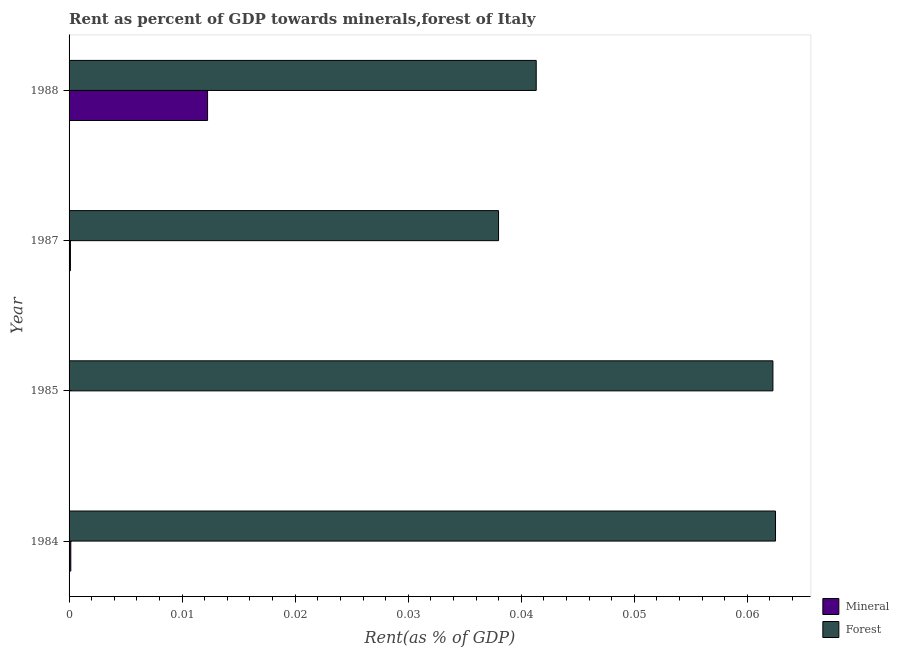How many different coloured bars are there?
Provide a short and direct response. 2. Are the number of bars per tick equal to the number of legend labels?
Provide a short and direct response. Yes. How many bars are there on the 4th tick from the top?
Ensure brevity in your answer.  2. In how many cases, is the number of bars for a given year not equal to the number of legend labels?
Provide a succinct answer. 0. What is the forest rent in 1984?
Ensure brevity in your answer.  0.06. Across all years, what is the maximum mineral rent?
Offer a terse response. 0.01. Across all years, what is the minimum forest rent?
Make the answer very short. 0.04. In which year was the mineral rent maximum?
Give a very brief answer. 1988. What is the total forest rent in the graph?
Offer a very short reply. 0.2. What is the difference between the forest rent in 1985 and that in 1988?
Provide a short and direct response. 0.02. What is the difference between the mineral rent in 1988 and the forest rent in 1987?
Offer a terse response. -0.03. What is the average mineral rent per year?
Provide a succinct answer. 0. In the year 1987, what is the difference between the mineral rent and forest rent?
Provide a succinct answer. -0.04. What is the ratio of the forest rent in 1985 to that in 1987?
Offer a terse response. 1.64. Is the difference between the mineral rent in 1984 and 1988 greater than the difference between the forest rent in 1984 and 1988?
Your response must be concise. No. What is the difference between the highest and the second highest mineral rent?
Keep it short and to the point. 0.01. In how many years, is the mineral rent greater than the average mineral rent taken over all years?
Give a very brief answer. 1. Is the sum of the forest rent in 1984 and 1985 greater than the maximum mineral rent across all years?
Offer a very short reply. Yes. What does the 1st bar from the top in 1987 represents?
Offer a very short reply. Forest. What does the 2nd bar from the bottom in 1987 represents?
Your response must be concise. Forest. Does the graph contain any zero values?
Ensure brevity in your answer.  No. Does the graph contain grids?
Offer a terse response. No. How many legend labels are there?
Your answer should be very brief. 2. How are the legend labels stacked?
Offer a terse response. Vertical. What is the title of the graph?
Keep it short and to the point. Rent as percent of GDP towards minerals,forest of Italy. What is the label or title of the X-axis?
Ensure brevity in your answer.  Rent(as % of GDP). What is the Rent(as % of GDP) in Mineral in 1984?
Provide a short and direct response. 0. What is the Rent(as % of GDP) in Forest in 1984?
Your answer should be very brief. 0.06. What is the Rent(as % of GDP) in Mineral in 1985?
Provide a succinct answer. 9.961583224840801e-6. What is the Rent(as % of GDP) in Forest in 1985?
Your answer should be compact. 0.06. What is the Rent(as % of GDP) in Mineral in 1987?
Make the answer very short. 0. What is the Rent(as % of GDP) in Forest in 1987?
Ensure brevity in your answer.  0.04. What is the Rent(as % of GDP) in Mineral in 1988?
Offer a very short reply. 0.01. What is the Rent(as % of GDP) of Forest in 1988?
Your answer should be very brief. 0.04. Across all years, what is the maximum Rent(as % of GDP) in Mineral?
Offer a very short reply. 0.01. Across all years, what is the maximum Rent(as % of GDP) of Forest?
Keep it short and to the point. 0.06. Across all years, what is the minimum Rent(as % of GDP) in Mineral?
Offer a terse response. 9.961583224840801e-6. Across all years, what is the minimum Rent(as % of GDP) in Forest?
Give a very brief answer. 0.04. What is the total Rent(as % of GDP) in Mineral in the graph?
Keep it short and to the point. 0.01. What is the total Rent(as % of GDP) in Forest in the graph?
Your answer should be compact. 0.2. What is the difference between the Rent(as % of GDP) of Mineral in 1984 and that in 1985?
Offer a very short reply. 0. What is the difference between the Rent(as % of GDP) of Forest in 1984 and that in 1987?
Make the answer very short. 0.02. What is the difference between the Rent(as % of GDP) in Mineral in 1984 and that in 1988?
Offer a terse response. -0.01. What is the difference between the Rent(as % of GDP) of Forest in 1984 and that in 1988?
Make the answer very short. 0.02. What is the difference between the Rent(as % of GDP) in Mineral in 1985 and that in 1987?
Provide a short and direct response. -0. What is the difference between the Rent(as % of GDP) of Forest in 1985 and that in 1987?
Ensure brevity in your answer.  0.02. What is the difference between the Rent(as % of GDP) in Mineral in 1985 and that in 1988?
Give a very brief answer. -0.01. What is the difference between the Rent(as % of GDP) in Forest in 1985 and that in 1988?
Your response must be concise. 0.02. What is the difference between the Rent(as % of GDP) of Mineral in 1987 and that in 1988?
Your response must be concise. -0.01. What is the difference between the Rent(as % of GDP) in Forest in 1987 and that in 1988?
Keep it short and to the point. -0. What is the difference between the Rent(as % of GDP) in Mineral in 1984 and the Rent(as % of GDP) in Forest in 1985?
Your answer should be compact. -0.06. What is the difference between the Rent(as % of GDP) of Mineral in 1984 and the Rent(as % of GDP) of Forest in 1987?
Give a very brief answer. -0.04. What is the difference between the Rent(as % of GDP) of Mineral in 1984 and the Rent(as % of GDP) of Forest in 1988?
Keep it short and to the point. -0.04. What is the difference between the Rent(as % of GDP) of Mineral in 1985 and the Rent(as % of GDP) of Forest in 1987?
Ensure brevity in your answer.  -0.04. What is the difference between the Rent(as % of GDP) of Mineral in 1985 and the Rent(as % of GDP) of Forest in 1988?
Offer a terse response. -0.04. What is the difference between the Rent(as % of GDP) of Mineral in 1987 and the Rent(as % of GDP) of Forest in 1988?
Your response must be concise. -0.04. What is the average Rent(as % of GDP) of Mineral per year?
Offer a terse response. 0. What is the average Rent(as % of GDP) of Forest per year?
Your answer should be very brief. 0.05. In the year 1984, what is the difference between the Rent(as % of GDP) in Mineral and Rent(as % of GDP) in Forest?
Ensure brevity in your answer.  -0.06. In the year 1985, what is the difference between the Rent(as % of GDP) in Mineral and Rent(as % of GDP) in Forest?
Your answer should be compact. -0.06. In the year 1987, what is the difference between the Rent(as % of GDP) in Mineral and Rent(as % of GDP) in Forest?
Your response must be concise. -0.04. In the year 1988, what is the difference between the Rent(as % of GDP) of Mineral and Rent(as % of GDP) of Forest?
Provide a short and direct response. -0.03. What is the ratio of the Rent(as % of GDP) in Mineral in 1984 to that in 1985?
Your answer should be very brief. 15.38. What is the ratio of the Rent(as % of GDP) of Forest in 1984 to that in 1985?
Keep it short and to the point. 1. What is the ratio of the Rent(as % of GDP) in Mineral in 1984 to that in 1987?
Make the answer very short. 1.28. What is the ratio of the Rent(as % of GDP) in Forest in 1984 to that in 1987?
Ensure brevity in your answer.  1.64. What is the ratio of the Rent(as % of GDP) in Mineral in 1984 to that in 1988?
Keep it short and to the point. 0.01. What is the ratio of the Rent(as % of GDP) in Forest in 1984 to that in 1988?
Your answer should be very brief. 1.51. What is the ratio of the Rent(as % of GDP) of Mineral in 1985 to that in 1987?
Your answer should be very brief. 0.08. What is the ratio of the Rent(as % of GDP) in Forest in 1985 to that in 1987?
Your response must be concise. 1.64. What is the ratio of the Rent(as % of GDP) in Mineral in 1985 to that in 1988?
Ensure brevity in your answer.  0. What is the ratio of the Rent(as % of GDP) of Forest in 1985 to that in 1988?
Give a very brief answer. 1.51. What is the ratio of the Rent(as % of GDP) of Mineral in 1987 to that in 1988?
Offer a terse response. 0.01. What is the ratio of the Rent(as % of GDP) of Forest in 1987 to that in 1988?
Keep it short and to the point. 0.92. What is the difference between the highest and the second highest Rent(as % of GDP) of Mineral?
Your response must be concise. 0.01. What is the difference between the highest and the second highest Rent(as % of GDP) of Forest?
Ensure brevity in your answer.  0. What is the difference between the highest and the lowest Rent(as % of GDP) of Mineral?
Your response must be concise. 0.01. What is the difference between the highest and the lowest Rent(as % of GDP) in Forest?
Offer a terse response. 0.02. 